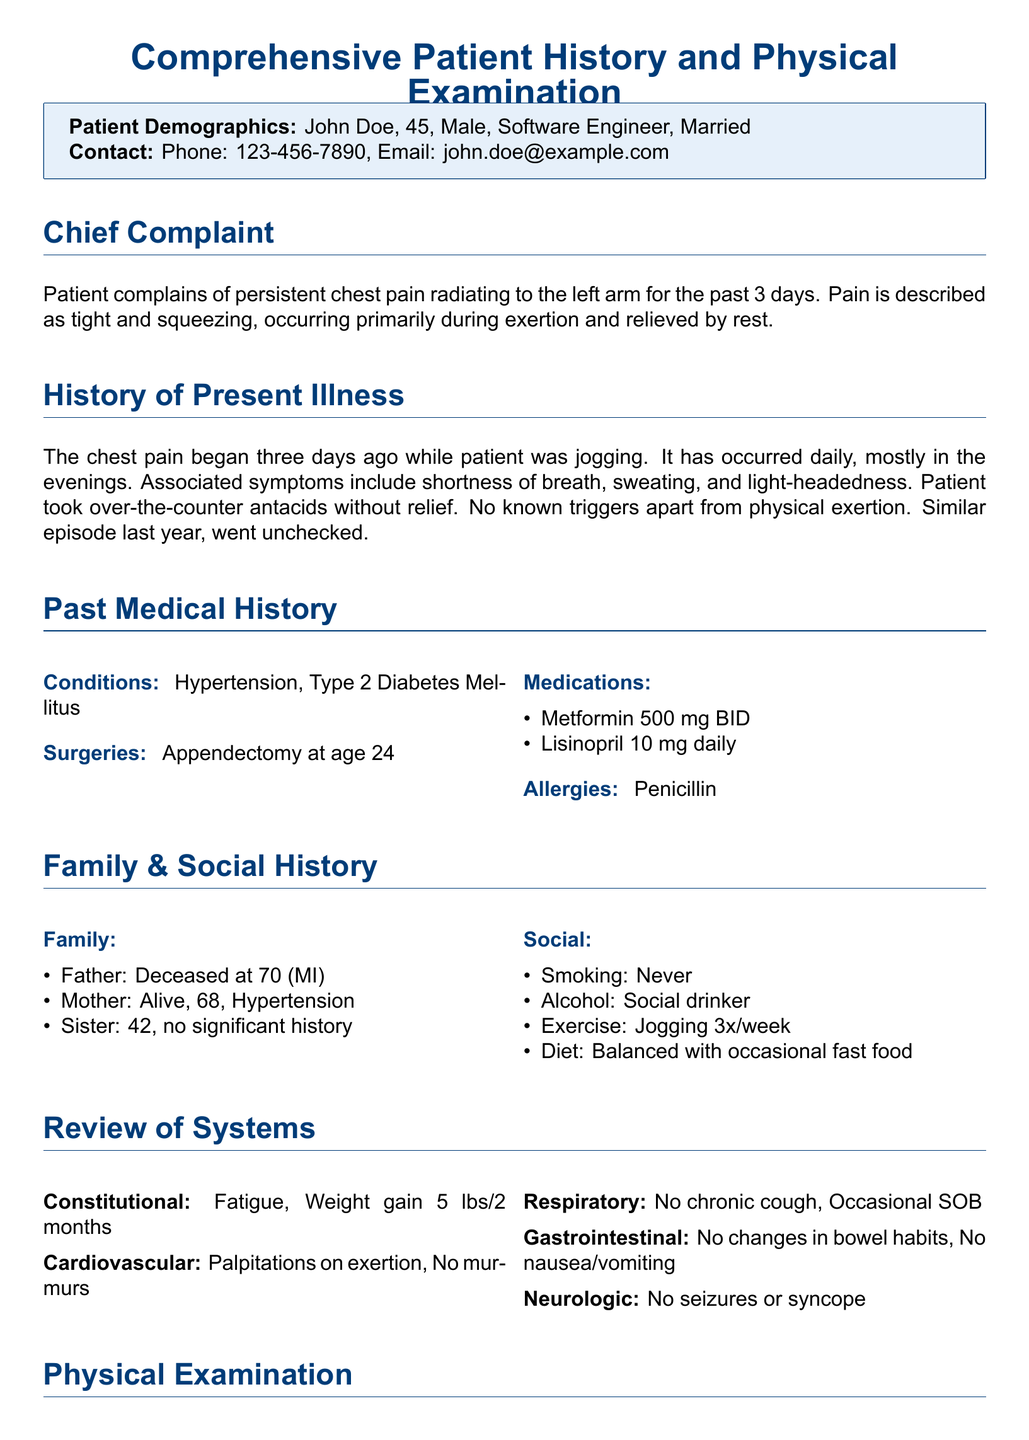What is the patient's name? The patient's name is stated in the demographics section.
Answer: John Doe How old is the patient? The age of the patient is provided in the demographics section.
Answer: 45 What is the chief complaint? The chief complaint is mentioned in the corresponding section of the document.
Answer: Persistent chest pain What medications is the patient currently taking? The medications taken by the patient are listed in the past medical history section.
Answer: Metformin and Lisinopril What was the result of the troponin I test? The result of the troponin I test is found in the diagnostic findings section.
Answer: Negative What does the ECG show? The results from the ECG are described in the diagnostic findings section.
Answer: Normal sinus rhythm What prior medical episode did the patient have? The medical history illustrates a previous episode relevant to the current condition.
Answer: Similar episode last year What lifestyle changes are recommended in the plan? The plan includes specific recommendations for lifestyle modifications.
Answer: Lifestyle modification counseling What is the plan for further evaluation? The plan includes a referral to a specialist for further assessment.
Answer: Refer to cardiologist 